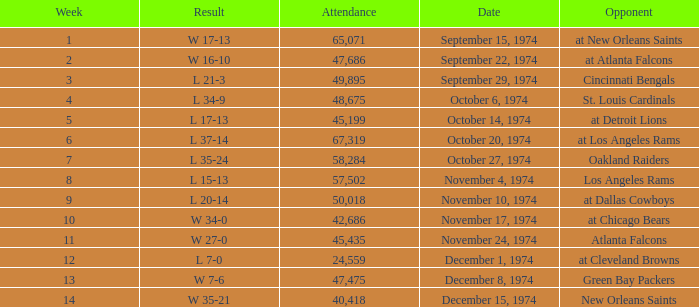What was the average attendance for games played at Atlanta Falcons? 47686.0. 